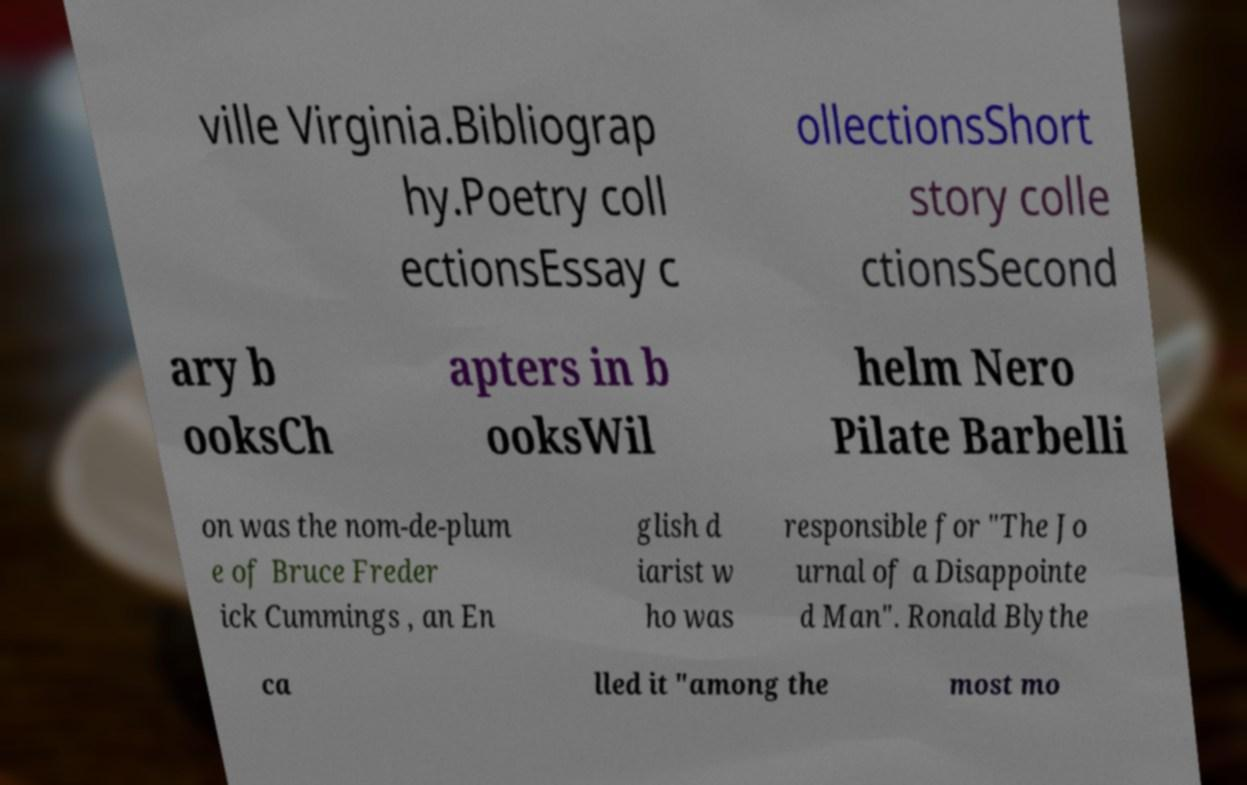For documentation purposes, I need the text within this image transcribed. Could you provide that? ville Virginia.Bibliograp hy.Poetry coll ectionsEssay c ollectionsShort story colle ctionsSecond ary b ooksCh apters in b ooksWil helm Nero Pilate Barbelli on was the nom-de-plum e of Bruce Freder ick Cummings , an En glish d iarist w ho was responsible for "The Jo urnal of a Disappointe d Man". Ronald Blythe ca lled it "among the most mo 